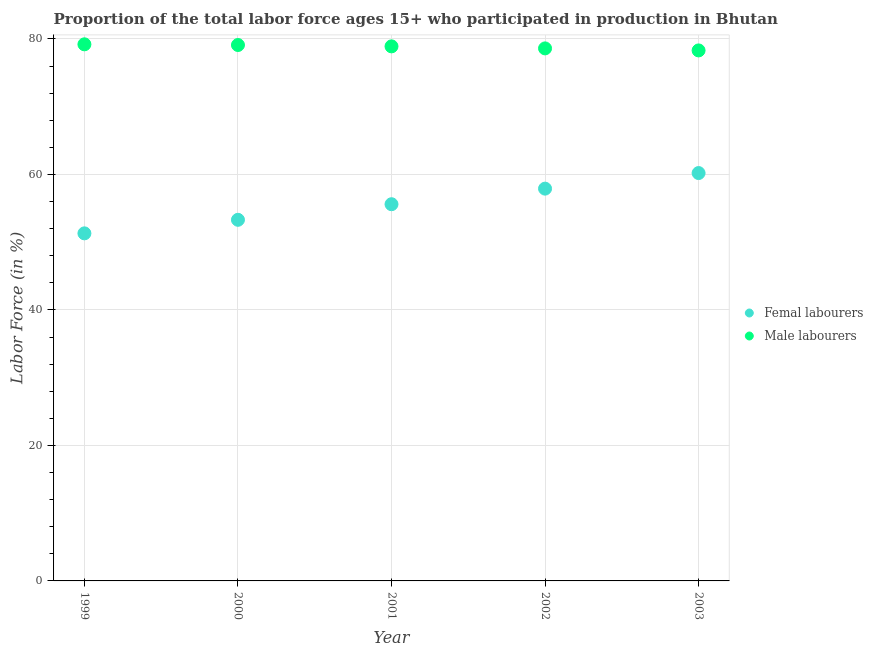What is the percentage of male labour force in 2001?
Offer a terse response. 78.9. Across all years, what is the maximum percentage of female labor force?
Make the answer very short. 60.2. Across all years, what is the minimum percentage of female labor force?
Your answer should be compact. 51.3. In which year was the percentage of female labor force minimum?
Your response must be concise. 1999. What is the total percentage of male labour force in the graph?
Ensure brevity in your answer.  394.1. What is the difference between the percentage of female labor force in 2001 and that in 2002?
Give a very brief answer. -2.3. What is the difference between the percentage of male labour force in 2001 and the percentage of female labor force in 2000?
Make the answer very short. 25.6. What is the average percentage of female labor force per year?
Your answer should be compact. 55.66. In the year 2001, what is the difference between the percentage of female labor force and percentage of male labour force?
Keep it short and to the point. -23.3. In how many years, is the percentage of male labour force greater than 24 %?
Give a very brief answer. 5. What is the ratio of the percentage of male labour force in 2001 to that in 2003?
Your response must be concise. 1.01. Is the percentage of male labour force in 2000 less than that in 2003?
Your answer should be compact. No. Is the difference between the percentage of female labor force in 2000 and 2001 greater than the difference between the percentage of male labour force in 2000 and 2001?
Provide a short and direct response. No. What is the difference between the highest and the second highest percentage of male labour force?
Offer a very short reply. 0.1. What is the difference between the highest and the lowest percentage of male labour force?
Offer a very short reply. 0.9. In how many years, is the percentage of male labour force greater than the average percentage of male labour force taken over all years?
Offer a terse response. 3. Is the sum of the percentage of male labour force in 2000 and 2002 greater than the maximum percentage of female labor force across all years?
Make the answer very short. Yes. Does the percentage of female labor force monotonically increase over the years?
Give a very brief answer. Yes. How many dotlines are there?
Offer a very short reply. 2. How many years are there in the graph?
Offer a terse response. 5. Does the graph contain any zero values?
Ensure brevity in your answer.  No. Where does the legend appear in the graph?
Ensure brevity in your answer.  Center right. How many legend labels are there?
Give a very brief answer. 2. How are the legend labels stacked?
Your answer should be very brief. Vertical. What is the title of the graph?
Ensure brevity in your answer.  Proportion of the total labor force ages 15+ who participated in production in Bhutan. What is the label or title of the X-axis?
Make the answer very short. Year. What is the Labor Force (in %) in Femal labourers in 1999?
Offer a very short reply. 51.3. What is the Labor Force (in %) in Male labourers in 1999?
Your response must be concise. 79.2. What is the Labor Force (in %) of Femal labourers in 2000?
Ensure brevity in your answer.  53.3. What is the Labor Force (in %) of Male labourers in 2000?
Your response must be concise. 79.1. What is the Labor Force (in %) of Femal labourers in 2001?
Offer a terse response. 55.6. What is the Labor Force (in %) of Male labourers in 2001?
Ensure brevity in your answer.  78.9. What is the Labor Force (in %) in Femal labourers in 2002?
Your answer should be very brief. 57.9. What is the Labor Force (in %) of Male labourers in 2002?
Make the answer very short. 78.6. What is the Labor Force (in %) in Femal labourers in 2003?
Your response must be concise. 60.2. What is the Labor Force (in %) of Male labourers in 2003?
Your answer should be compact. 78.3. Across all years, what is the maximum Labor Force (in %) of Femal labourers?
Ensure brevity in your answer.  60.2. Across all years, what is the maximum Labor Force (in %) in Male labourers?
Your response must be concise. 79.2. Across all years, what is the minimum Labor Force (in %) in Femal labourers?
Your answer should be very brief. 51.3. Across all years, what is the minimum Labor Force (in %) in Male labourers?
Give a very brief answer. 78.3. What is the total Labor Force (in %) in Femal labourers in the graph?
Your response must be concise. 278.3. What is the total Labor Force (in %) of Male labourers in the graph?
Your response must be concise. 394.1. What is the difference between the Labor Force (in %) of Male labourers in 1999 and that in 2000?
Keep it short and to the point. 0.1. What is the difference between the Labor Force (in %) of Femal labourers in 1999 and that in 2001?
Offer a very short reply. -4.3. What is the difference between the Labor Force (in %) in Male labourers in 1999 and that in 2002?
Give a very brief answer. 0.6. What is the difference between the Labor Force (in %) of Femal labourers in 1999 and that in 2003?
Provide a succinct answer. -8.9. What is the difference between the Labor Force (in %) in Male labourers in 2000 and that in 2001?
Your answer should be compact. 0.2. What is the difference between the Labor Force (in %) in Femal labourers in 2000 and that in 2002?
Your response must be concise. -4.6. What is the difference between the Labor Force (in %) in Femal labourers in 2001 and that in 2002?
Provide a short and direct response. -2.3. What is the difference between the Labor Force (in %) of Male labourers in 2001 and that in 2003?
Offer a terse response. 0.6. What is the difference between the Labor Force (in %) in Femal labourers in 1999 and the Labor Force (in %) in Male labourers in 2000?
Make the answer very short. -27.8. What is the difference between the Labor Force (in %) of Femal labourers in 1999 and the Labor Force (in %) of Male labourers in 2001?
Make the answer very short. -27.6. What is the difference between the Labor Force (in %) of Femal labourers in 1999 and the Labor Force (in %) of Male labourers in 2002?
Your answer should be very brief. -27.3. What is the difference between the Labor Force (in %) of Femal labourers in 1999 and the Labor Force (in %) of Male labourers in 2003?
Keep it short and to the point. -27. What is the difference between the Labor Force (in %) of Femal labourers in 2000 and the Labor Force (in %) of Male labourers in 2001?
Provide a succinct answer. -25.6. What is the difference between the Labor Force (in %) of Femal labourers in 2000 and the Labor Force (in %) of Male labourers in 2002?
Your answer should be compact. -25.3. What is the difference between the Labor Force (in %) of Femal labourers in 2000 and the Labor Force (in %) of Male labourers in 2003?
Make the answer very short. -25. What is the difference between the Labor Force (in %) of Femal labourers in 2001 and the Labor Force (in %) of Male labourers in 2003?
Your response must be concise. -22.7. What is the difference between the Labor Force (in %) of Femal labourers in 2002 and the Labor Force (in %) of Male labourers in 2003?
Provide a succinct answer. -20.4. What is the average Labor Force (in %) in Femal labourers per year?
Offer a terse response. 55.66. What is the average Labor Force (in %) in Male labourers per year?
Your answer should be very brief. 78.82. In the year 1999, what is the difference between the Labor Force (in %) in Femal labourers and Labor Force (in %) in Male labourers?
Keep it short and to the point. -27.9. In the year 2000, what is the difference between the Labor Force (in %) of Femal labourers and Labor Force (in %) of Male labourers?
Your answer should be compact. -25.8. In the year 2001, what is the difference between the Labor Force (in %) in Femal labourers and Labor Force (in %) in Male labourers?
Offer a very short reply. -23.3. In the year 2002, what is the difference between the Labor Force (in %) of Femal labourers and Labor Force (in %) of Male labourers?
Your answer should be compact. -20.7. In the year 2003, what is the difference between the Labor Force (in %) in Femal labourers and Labor Force (in %) in Male labourers?
Provide a short and direct response. -18.1. What is the ratio of the Labor Force (in %) of Femal labourers in 1999 to that in 2000?
Offer a very short reply. 0.96. What is the ratio of the Labor Force (in %) of Male labourers in 1999 to that in 2000?
Provide a succinct answer. 1. What is the ratio of the Labor Force (in %) of Femal labourers in 1999 to that in 2001?
Give a very brief answer. 0.92. What is the ratio of the Labor Force (in %) in Male labourers in 1999 to that in 2001?
Offer a very short reply. 1. What is the ratio of the Labor Force (in %) of Femal labourers in 1999 to that in 2002?
Offer a terse response. 0.89. What is the ratio of the Labor Force (in %) of Male labourers in 1999 to that in 2002?
Provide a succinct answer. 1.01. What is the ratio of the Labor Force (in %) of Femal labourers in 1999 to that in 2003?
Your answer should be very brief. 0.85. What is the ratio of the Labor Force (in %) of Male labourers in 1999 to that in 2003?
Provide a short and direct response. 1.01. What is the ratio of the Labor Force (in %) of Femal labourers in 2000 to that in 2001?
Your answer should be very brief. 0.96. What is the ratio of the Labor Force (in %) in Male labourers in 2000 to that in 2001?
Offer a terse response. 1. What is the ratio of the Labor Force (in %) in Femal labourers in 2000 to that in 2002?
Make the answer very short. 0.92. What is the ratio of the Labor Force (in %) of Male labourers in 2000 to that in 2002?
Your answer should be very brief. 1.01. What is the ratio of the Labor Force (in %) of Femal labourers in 2000 to that in 2003?
Your response must be concise. 0.89. What is the ratio of the Labor Force (in %) of Male labourers in 2000 to that in 2003?
Provide a succinct answer. 1.01. What is the ratio of the Labor Force (in %) of Femal labourers in 2001 to that in 2002?
Give a very brief answer. 0.96. What is the ratio of the Labor Force (in %) in Femal labourers in 2001 to that in 2003?
Offer a terse response. 0.92. What is the ratio of the Labor Force (in %) of Male labourers in 2001 to that in 2003?
Your response must be concise. 1.01. What is the ratio of the Labor Force (in %) in Femal labourers in 2002 to that in 2003?
Keep it short and to the point. 0.96. What is the ratio of the Labor Force (in %) in Male labourers in 2002 to that in 2003?
Provide a short and direct response. 1. What is the difference between the highest and the lowest Labor Force (in %) of Male labourers?
Your response must be concise. 0.9. 